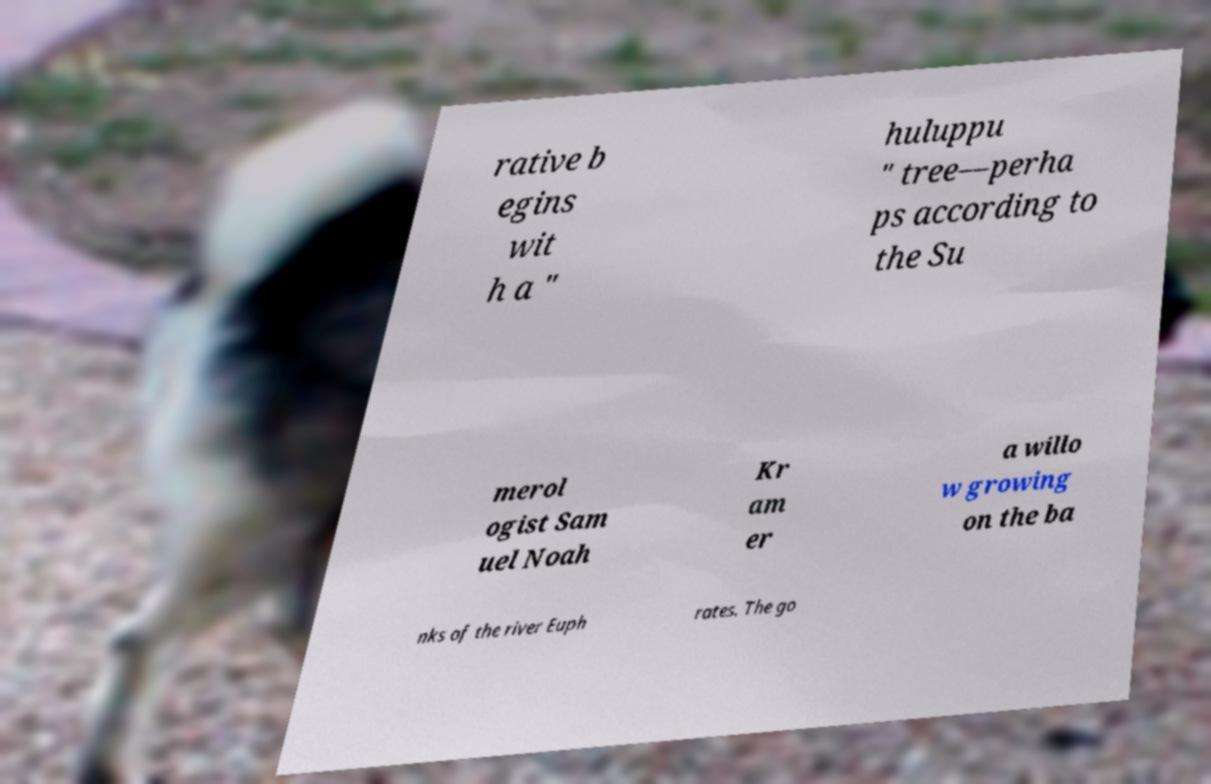Could you assist in decoding the text presented in this image and type it out clearly? rative b egins wit h a " huluppu " tree—perha ps according to the Su merol ogist Sam uel Noah Kr am er a willo w growing on the ba nks of the river Euph rates. The go 